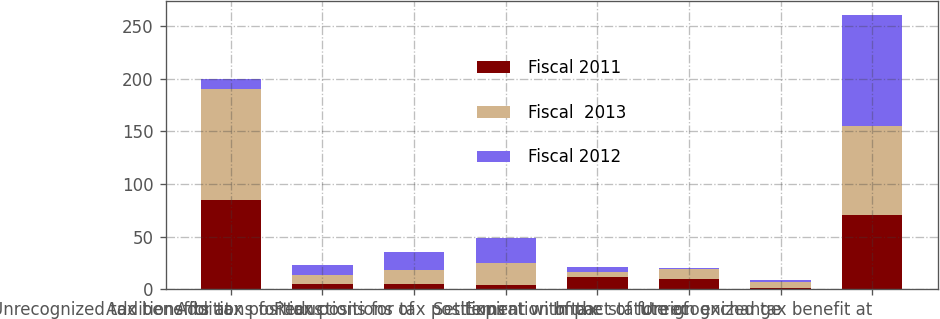Convert chart. <chart><loc_0><loc_0><loc_500><loc_500><stacked_bar_chart><ecel><fcel>Unrecognized tax benefits at<fcel>Additions for tax positions<fcel>Additions for tax positions of<fcel>Reductions for tax positions<fcel>Settlement with tax<fcel>Expiration of the statute of<fcel>Impact of foreign exchange<fcel>Unrecognized tax benefit at<nl><fcel>Fiscal 2011<fcel>84.7<fcel>5<fcel>5.3<fcel>3.7<fcel>12<fcel>9.7<fcel>1.1<fcel>70.7<nl><fcel>Fiscal  2013<fcel>105.7<fcel>8<fcel>13<fcel>21.6<fcel>4.2<fcel>9.8<fcel>5.6<fcel>84.7<nl><fcel>Fiscal 2012<fcel>9.7<fcel>9.7<fcel>17.3<fcel>23.3<fcel>4.5<fcel>0.4<fcel>2.1<fcel>105.7<nl></chart> 